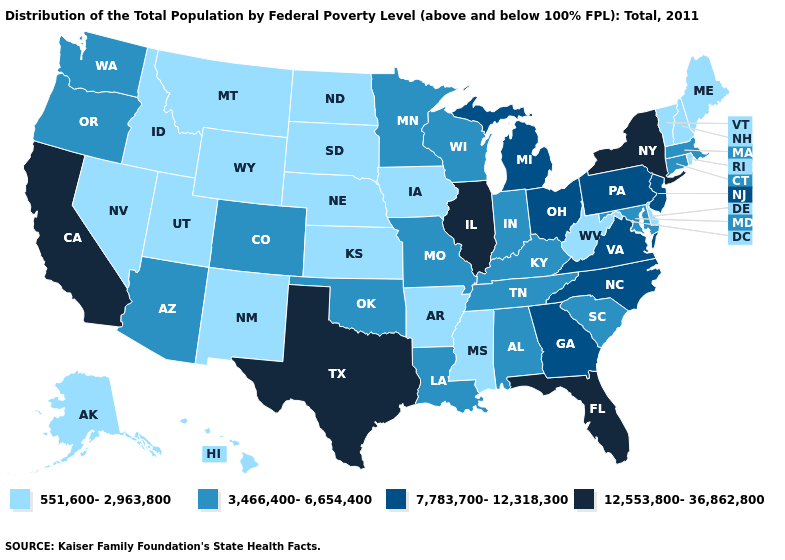Name the states that have a value in the range 12,553,800-36,862,800?
Be succinct. California, Florida, Illinois, New York, Texas. Does Oregon have the highest value in the USA?
Be succinct. No. What is the value of Oregon?
Be succinct. 3,466,400-6,654,400. Name the states that have a value in the range 3,466,400-6,654,400?
Concise answer only. Alabama, Arizona, Colorado, Connecticut, Indiana, Kentucky, Louisiana, Maryland, Massachusetts, Minnesota, Missouri, Oklahoma, Oregon, South Carolina, Tennessee, Washington, Wisconsin. What is the value of Alabama?
Short answer required. 3,466,400-6,654,400. Name the states that have a value in the range 12,553,800-36,862,800?
Give a very brief answer. California, Florida, Illinois, New York, Texas. Does Florida have the lowest value in the USA?
Concise answer only. No. Name the states that have a value in the range 12,553,800-36,862,800?
Concise answer only. California, Florida, Illinois, New York, Texas. How many symbols are there in the legend?
Quick response, please. 4. Does Texas have the highest value in the South?
Short answer required. Yes. What is the lowest value in the West?
Write a very short answer. 551,600-2,963,800. Among the states that border Michigan , does Ohio have the highest value?
Quick response, please. Yes. Does North Dakota have the highest value in the USA?
Keep it brief. No. What is the value of New Jersey?
Give a very brief answer. 7,783,700-12,318,300. Does New York have the highest value in the USA?
Be succinct. Yes. 